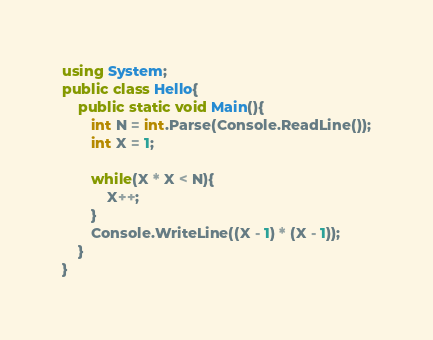Convert code to text. <code><loc_0><loc_0><loc_500><loc_500><_C#_>using System;
public class Hello{
    public static void Main(){
       int N = int.Parse(Console.ReadLine());
       int X = 1;
       
       while(X * X < N){
           X++;
       }
       Console.WriteLine((X - 1) * (X - 1));
    }
}</code> 